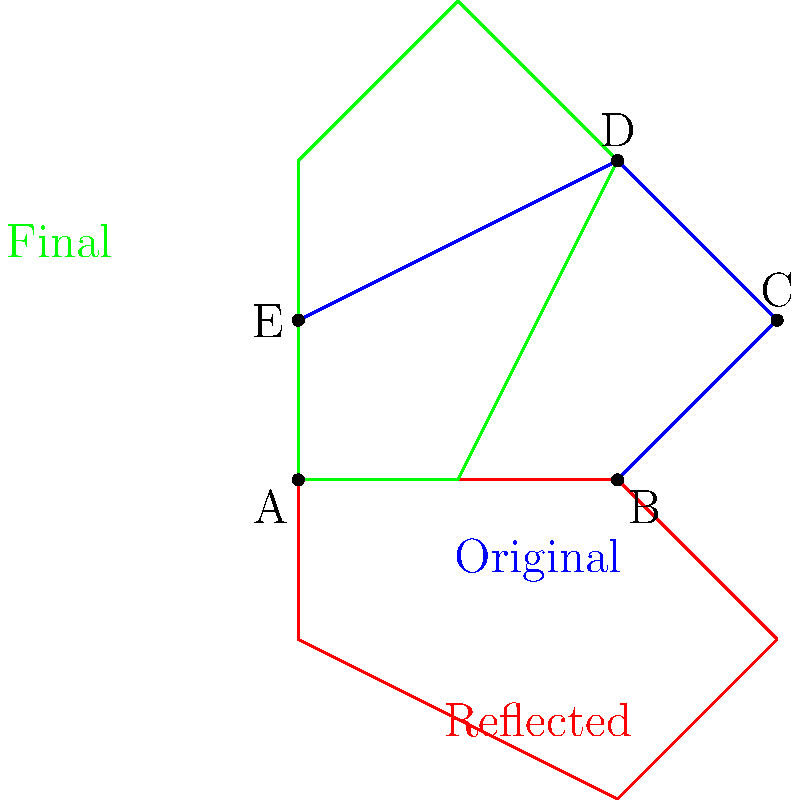In JetPack Compose, you're implementing a custom animation for a pentagon shape. The animation involves a sequence of transformations: first, the pentagon is reflected across the line AB, then rotated 90 degrees counterclockwise around point A. Given the original pentagon ABCDE, what is the final position of point C after both transformations? Let's break this down step-by-step:

1) First, we reflect the pentagon across line AB:
   - Points A and B remain unchanged.
   - Point C (3,1) is reflected to (3,-1).
   - Point D (2,2) is reflected to (2,-2).
   - Point E (0,1) is reflected to (0,-1).

2) Next, we rotate the reflected pentagon 90 degrees counterclockwise around point A:
   - Rotation by 90 degrees counterclockwise can be achieved by:
     $$(x,y) \rightarrow (-y,x)$$

3) Applying this rotation to the reflected point C (3,-1):
   $$(3,-1) \rightarrow (1,3)$$

Therefore, after both transformations, point C ends up at (1,3).

In JetPack Compose, you would implement these transformations using the `graphicsLayer` modifier, applying `rotationZ` and custom transformation matrices for reflection.
Answer: (1,3) 